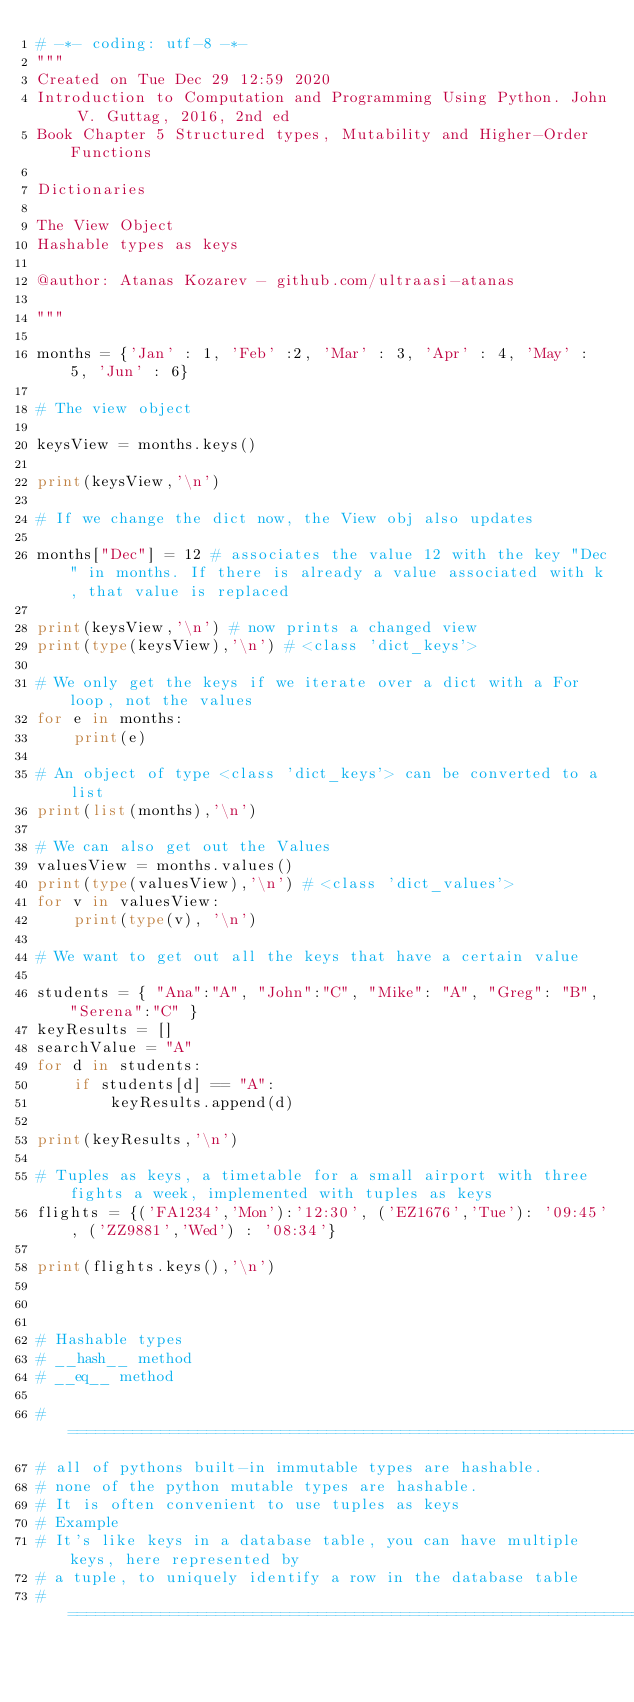Convert code to text. <code><loc_0><loc_0><loc_500><loc_500><_Python_># -*- coding: utf-8 -*-
"""
Created on Tue Dec 29 12:59 2020
Introduction to Computation and Programming Using Python. John V. Guttag, 2016, 2nd ed
Book Chapter 5 Structured types, Mutability and Higher-Order Functions

Dictionaries 

The View Object
Hashable types as keys

@author: Atanas Kozarev - github.com/ultraasi-atanas

"""

months = {'Jan' : 1, 'Feb' :2, 'Mar' : 3, 'Apr' : 4, 'May' : 5, 'Jun' : 6}

# The view object

keysView = months.keys()

print(keysView,'\n')

# If we change the dict now, the View obj also updates

months["Dec"] = 12 # associates the value 12 with the key "Dec" in months. If there is already a value associated with k, that value is replaced

print(keysView,'\n') # now prints a changed view
print(type(keysView),'\n') # <class 'dict_keys'>

# We only get the keys if we iterate over a dict with a For loop, not the values
for e in months:
    print(e)
        
# An object of type <class 'dict_keys'> can be converted to a list
print(list(months),'\n')    

# We can also get out the Values
valuesView = months.values()
print(type(valuesView),'\n') # <class 'dict_values'>
for v in valuesView:
    print(type(v), '\n')

# We want to get out all the keys that have a certain value

students = { "Ana":"A", "John":"C", "Mike": "A", "Greg": "B", "Serena":"C" }
keyResults = []
searchValue = "A"
for d in students:
    if students[d] == "A":
        keyResults.append(d)
        
print(keyResults,'\n')
    
# Tuples as keys, a timetable for a small airport with three fights a week, implemented with tuples as keys
flights = {('FA1234','Mon'):'12:30', ('EZ1676','Tue'): '09:45', ('ZZ9881','Wed') : '08:34'}

print(flights.keys(),'\n')



# Hashable types
# __hash__ method
# __eq__ method

# =============================================================================
# all of pythons built-in immutable types are hashable. 
# none of the python mutable types are hashable.
# It is often convenient to use tuples as keys
# Example
# It's like keys in a database table, you can have multiple keys, here represented by
# a tuple, to uniquely identify a row in the database table
# =============================================================================

</code> 